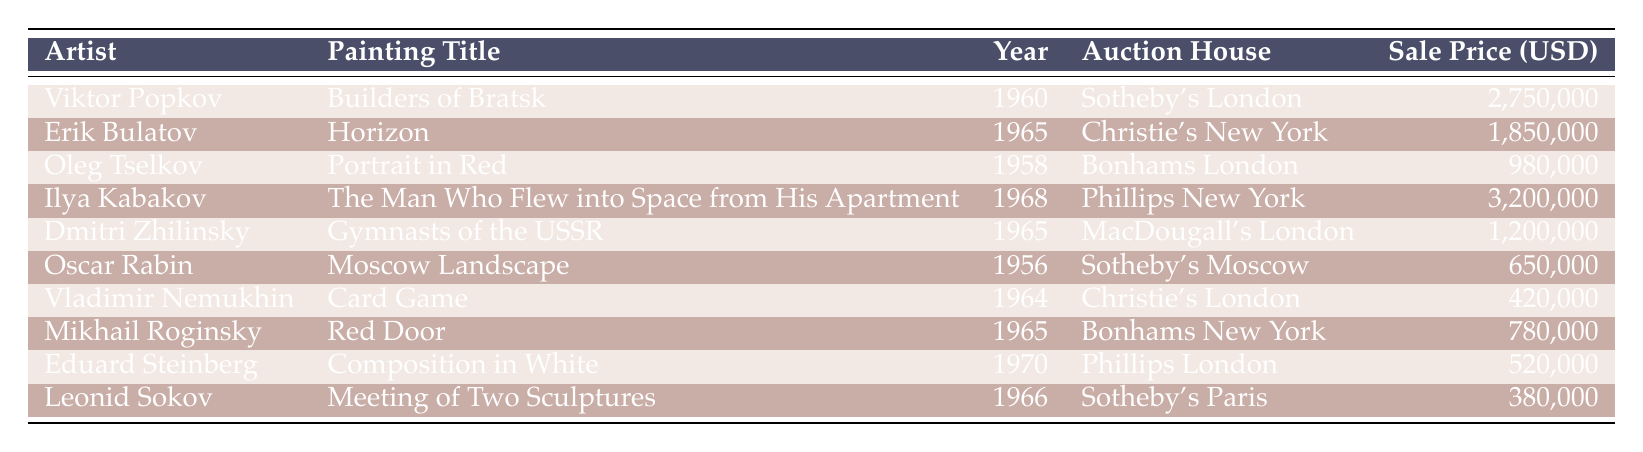What is the highest sale price for a painting in the table? The table shows ten entries with their respective sale prices. By scanning the 'Sale Price (USD)' column, the highest price listed is for "The Man Who Flew into Space from His Apartment" by Ilya Kabakov at 3,200,000 USD.
Answer: 3,200,000 Which artist has the painting titled "Horizon"? The title "Horizon" appears in the table under the artist Erik Bulatov for the year 1965 at Christie's New York.
Answer: Erik Bulatov What is the average sale price of the paintings from 1965? The paintings from 1965 are "Horizon" (1,850,000), "Gymnasts of the USSR" (1,200,000), and "Red Door" (780,000). Adding these values gives 1,850,000 + 1,200,000 + 780,000 = 3,830,000. There are three items, so the average price is 3,830,000 / 3 = 1,276,667.
Answer: 1,276,667 Did any painting sell for less than 500,000 USD? By examining the sale prices in the table, the lowest price is 380,000 for "Meeting of Two Sculptures" by Leonid Sokov, which is indeed less than 500,000 USD.
Answer: Yes Which auction house had the painting with the lowest price? The painting with the lowest sale price, "Meeting of Two Sculptures" by Leonid Sokov, sold for 380,000 at Sotheby's Paris. Scanning the table reveals that Sotheby's is mentioned for this painting, making it the auction house with the lowest sale price.
Answer: Sotheby's Paris 